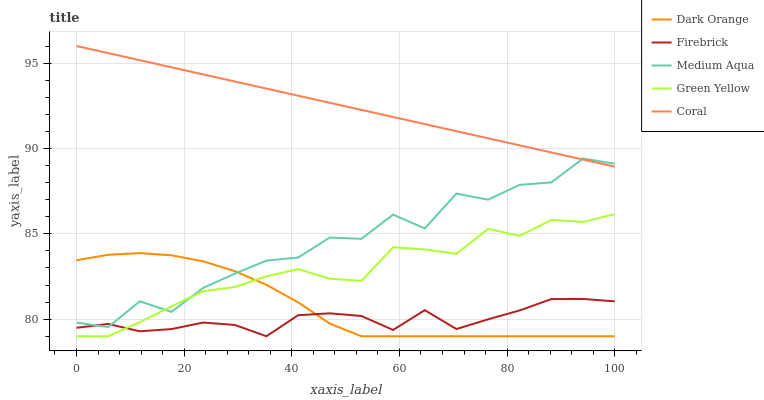Does Firebrick have the minimum area under the curve?
Answer yes or no. Yes. Does Coral have the maximum area under the curve?
Answer yes or no. Yes. Does Green Yellow have the minimum area under the curve?
Answer yes or no. No. Does Green Yellow have the maximum area under the curve?
Answer yes or no. No. Is Coral the smoothest?
Answer yes or no. Yes. Is Medium Aqua the roughest?
Answer yes or no. Yes. Is Firebrick the smoothest?
Answer yes or no. No. Is Firebrick the roughest?
Answer yes or no. No. Does Dark Orange have the lowest value?
Answer yes or no. Yes. Does Medium Aqua have the lowest value?
Answer yes or no. No. Does Coral have the highest value?
Answer yes or no. Yes. Does Green Yellow have the highest value?
Answer yes or no. No. Is Firebrick less than Coral?
Answer yes or no. Yes. Is Coral greater than Dark Orange?
Answer yes or no. Yes. Does Dark Orange intersect Medium Aqua?
Answer yes or no. Yes. Is Dark Orange less than Medium Aqua?
Answer yes or no. No. Is Dark Orange greater than Medium Aqua?
Answer yes or no. No. Does Firebrick intersect Coral?
Answer yes or no. No. 